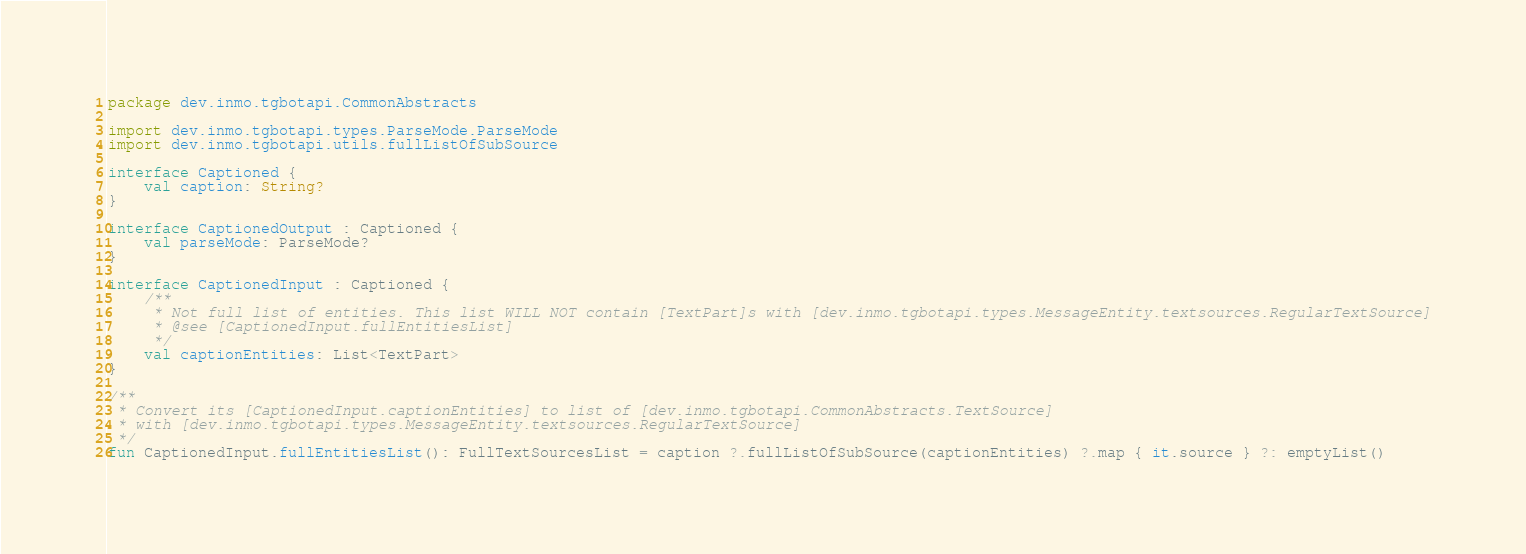Convert code to text. <code><loc_0><loc_0><loc_500><loc_500><_Kotlin_>package dev.inmo.tgbotapi.CommonAbstracts

import dev.inmo.tgbotapi.types.ParseMode.ParseMode
import dev.inmo.tgbotapi.utils.fullListOfSubSource

interface Captioned {
    val caption: String?
}

interface CaptionedOutput : Captioned {
    val parseMode: ParseMode?
}

interface CaptionedInput : Captioned {
    /**
     * Not full list of entities. This list WILL NOT contain [TextPart]s with [dev.inmo.tgbotapi.types.MessageEntity.textsources.RegularTextSource]
     * @see [CaptionedInput.fullEntitiesList]
     */
    val captionEntities: List<TextPart>
}

/**
 * Convert its [CaptionedInput.captionEntities] to list of [dev.inmo.tgbotapi.CommonAbstracts.TextSource]
 * with [dev.inmo.tgbotapi.types.MessageEntity.textsources.RegularTextSource]
 */
fun CaptionedInput.fullEntitiesList(): FullTextSourcesList = caption ?.fullListOfSubSource(captionEntities) ?.map { it.source } ?: emptyList()
</code> 